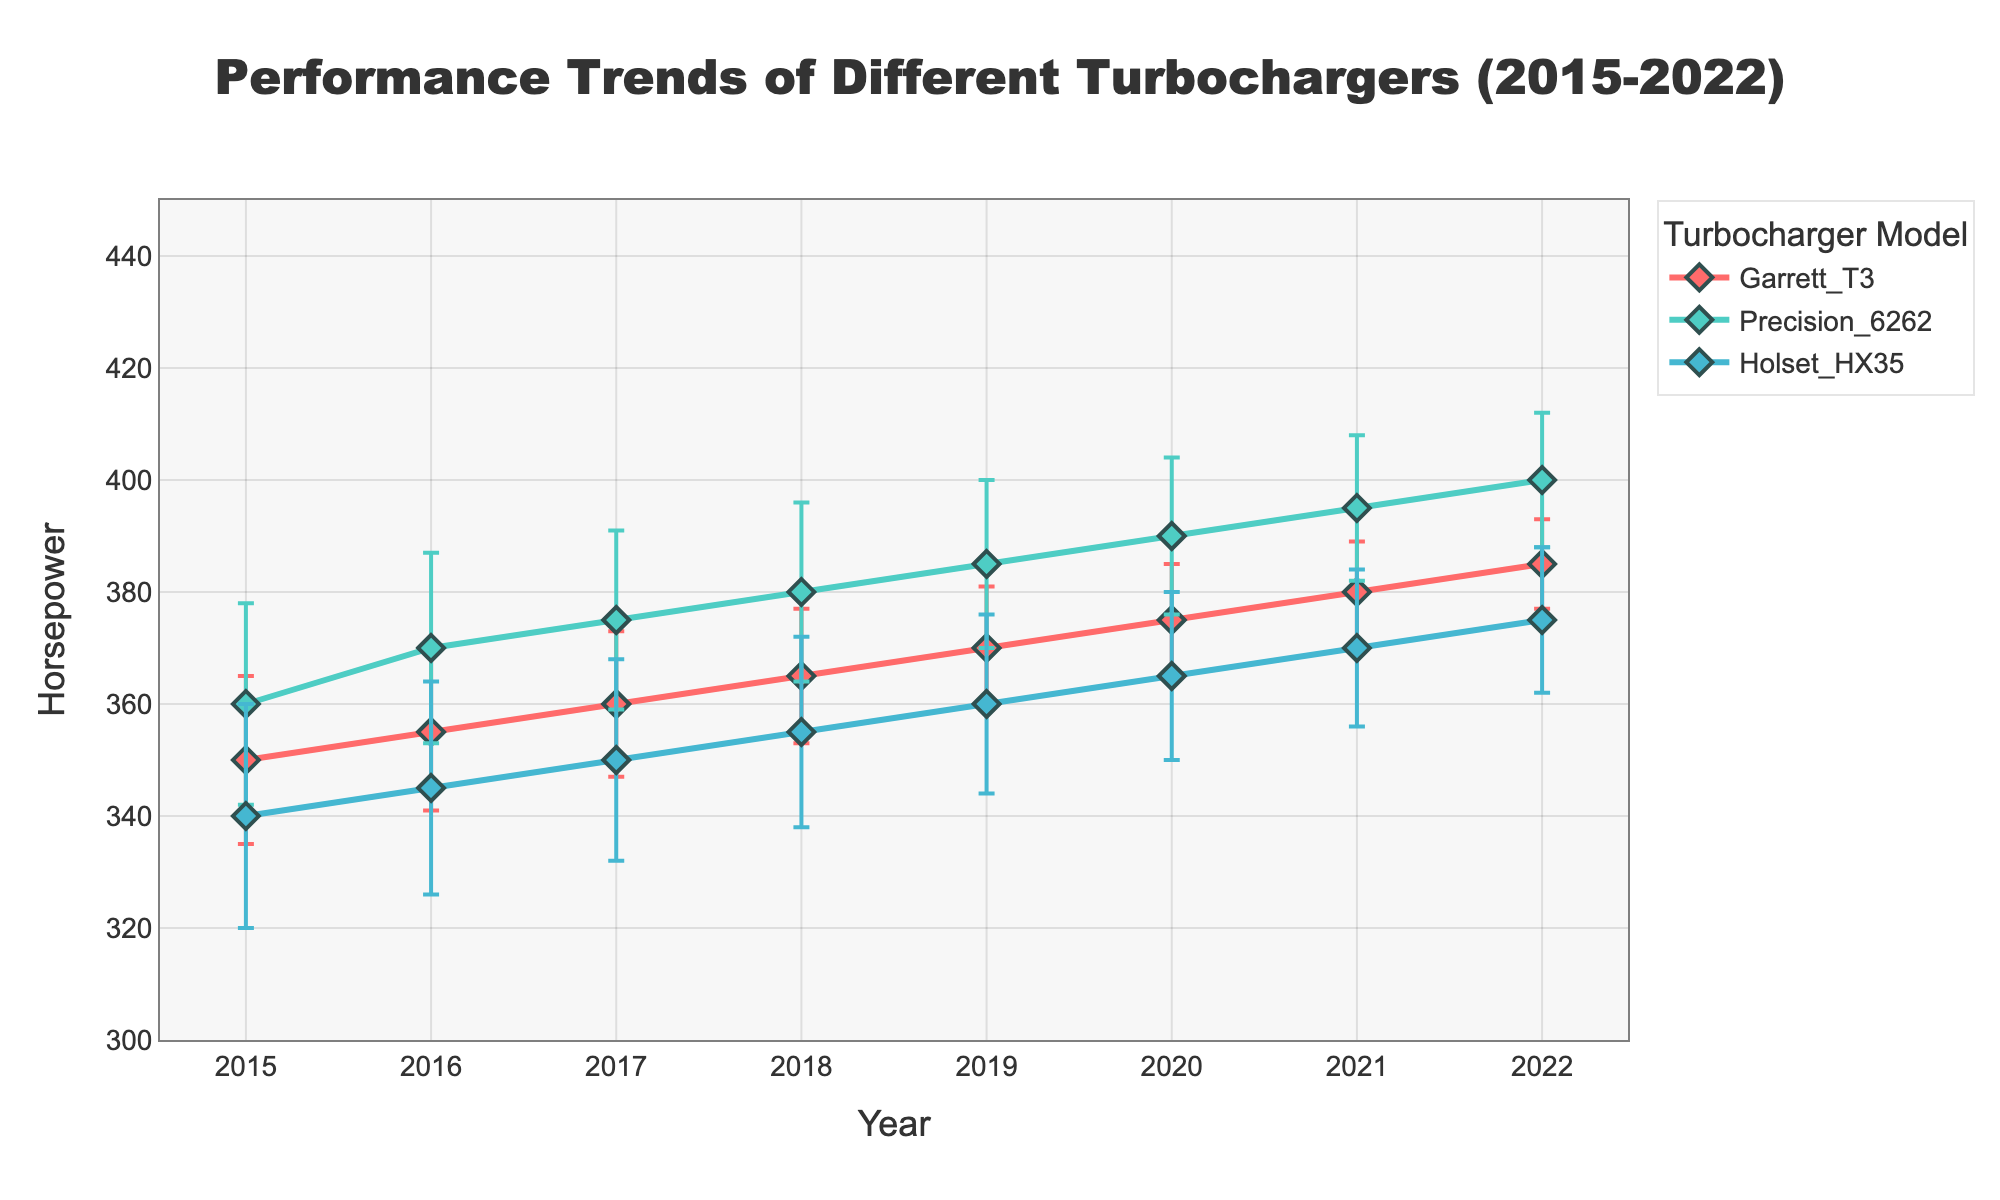What's the title of the plot? The title of the plot is located at the top center of the figure and is styled to stand out with a font size larger than the rest of the text.
Answer: Performance Trends of Different Turbochargers (2015-2022) Which turbocharger model shows the highest mean horsepower in 2022? From the plot, examine the data points for the year 2022. The peak data point corresponds to the Precision 6262 turbocharger.
Answer: Precision 6262 In 2017, which turbocharger had the lowest mean horsepower? Look at the data points for the year 2017 and compare the mean horsepower values of the three turbochargers. Holset HX35 has the lowest value.
Answer: Holset HX35 How does the variability in horsepower for the Garrett T3 turbocharger change from 2015 to 2022? Observe the error bars (which represent the standard deviation) for the Garrett T3 across the years. The length of the error bars decreases from 2015 to 2022, indicating reduced variability.
Answer: It decreases Compare the mean horsepower between Precision 6262 and Garrett T3 in 2020. Which one is higher and by how much? Check the mean horsepower values for both turbochargers in 2020. Precision 6262 has 390 HP, while Garrett T3 has 375 HP. The difference is 15 HP.
Answer: Precision 6262 by 15 HP Which year shows the highest mean horsepower for the Holset HX35 turbocharger? Examine the data points for Holset HX35 across all years. The highest mean horsepower for Holset HX35 is observed in 2022.
Answer: 2022 Calculate the average mean horsepower of the Garrett T3 turbocharger over the entire period (2015-2022). Sum the mean horsepower values of the Garrett T3 from 2015 to 2022 and then divide by the number of years (8). (350 + 355 + 360 + 365 + 370 + 375 + 380 + 385) / 8 = 365
Answer: 365 How does the mean horsepower of the Precision 6262 in 2018 compare to its value in 2019? Locate the data points for Precision 6262 in 2018 and 2019. The mean horsepower increases from 380 HP in 2018 to 385 HP in 2019.
Answer: It increased by 5 HP What is the trend observed for the mean horsepower of all three turbochargers from 2015 to 2022? The trend for all three turbochargers is an increase in mean horsepower over time.
Answer: Increasing How does the error bar length for the Holset HX35 in 2015 compare to that in 2022? Compare the lengths of the error bars for the Holset HX35 data points in 2015 and 2022. The error bars are longer in 2015 than in 2022, indicating greater variability in 2015.
Answer: Longer in 2015 